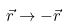<formula> <loc_0><loc_0><loc_500><loc_500>\vec { r } \rightarrow - \vec { r }</formula> 